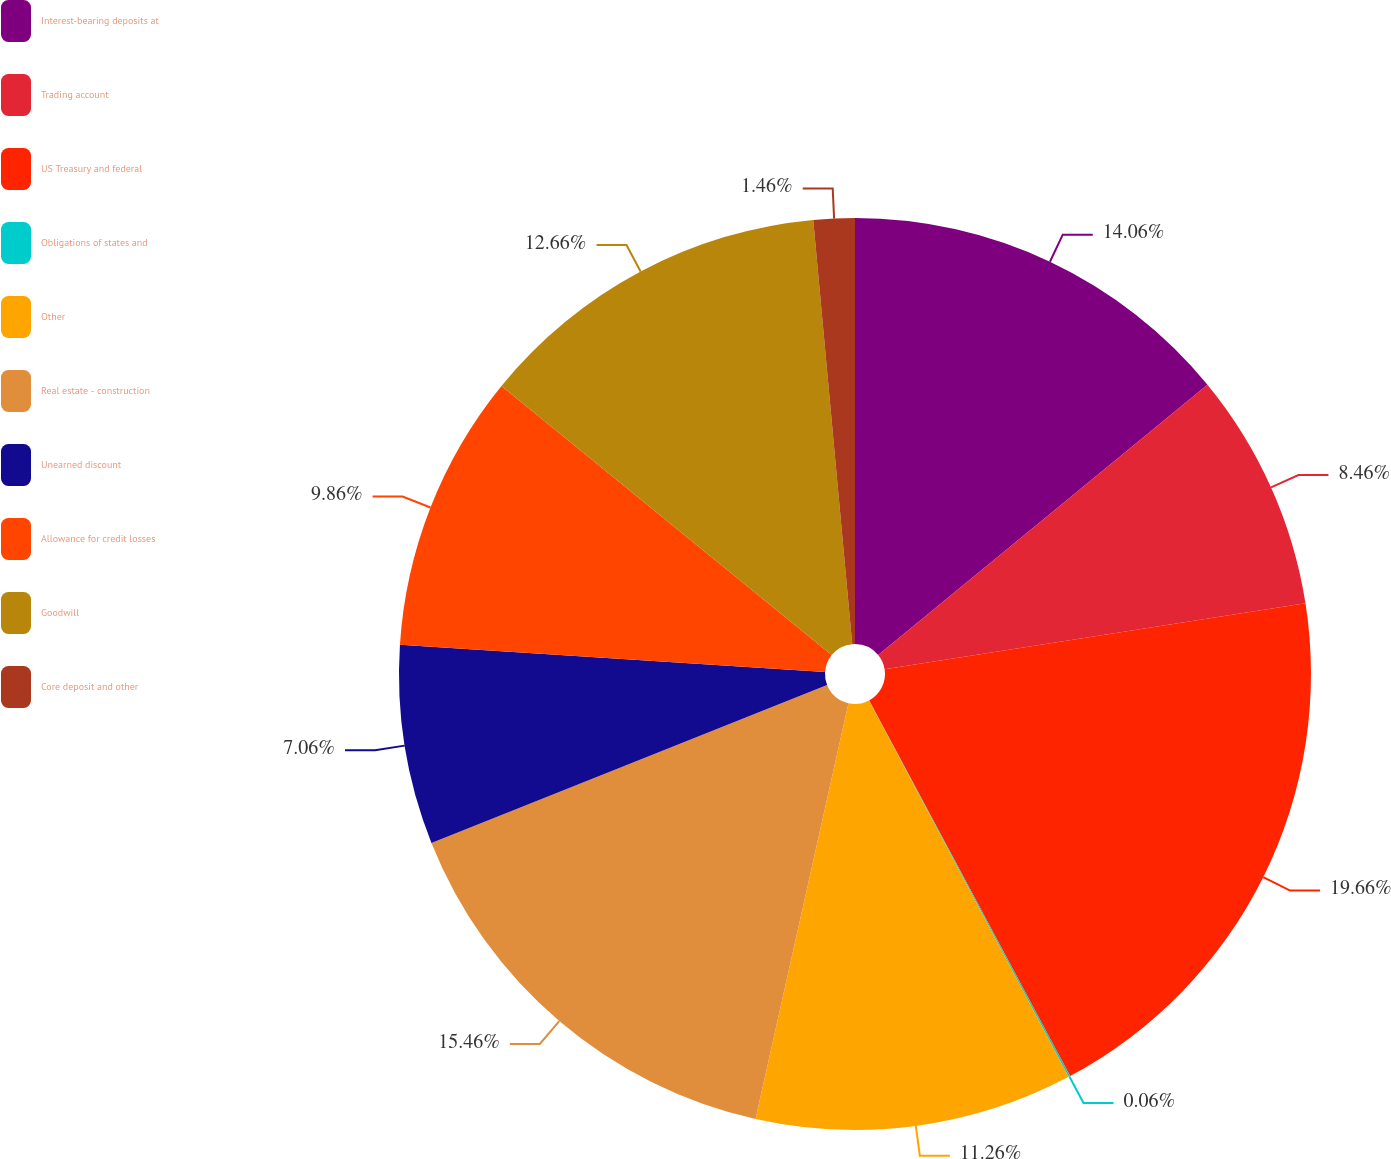Convert chart to OTSL. <chart><loc_0><loc_0><loc_500><loc_500><pie_chart><fcel>Interest-bearing deposits at<fcel>Trading account<fcel>US Treasury and federal<fcel>Obligations of states and<fcel>Other<fcel>Real estate - construction<fcel>Unearned discount<fcel>Allowance for credit losses<fcel>Goodwill<fcel>Core deposit and other<nl><fcel>14.06%<fcel>8.46%<fcel>19.66%<fcel>0.06%<fcel>11.26%<fcel>15.46%<fcel>7.06%<fcel>9.86%<fcel>12.66%<fcel>1.46%<nl></chart> 